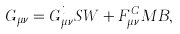Convert formula to latex. <formula><loc_0><loc_0><loc_500><loc_500>G _ { \mu \nu } = G _ { \mu \nu } ^ { i } S W + F _ { \mu \nu } ^ { C } M B ,</formula> 